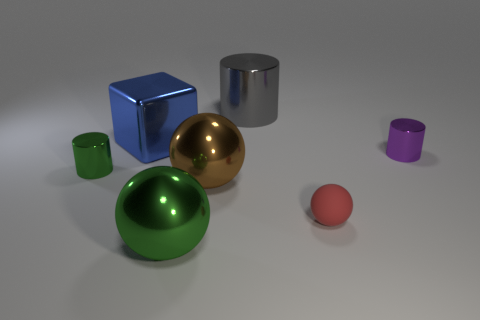Can you tell me which objects are reflective? Certainly! In the image, the objects with reflective surfaces include the blue cube, the silver cylinder, the gold sphere, and the green sphere. 